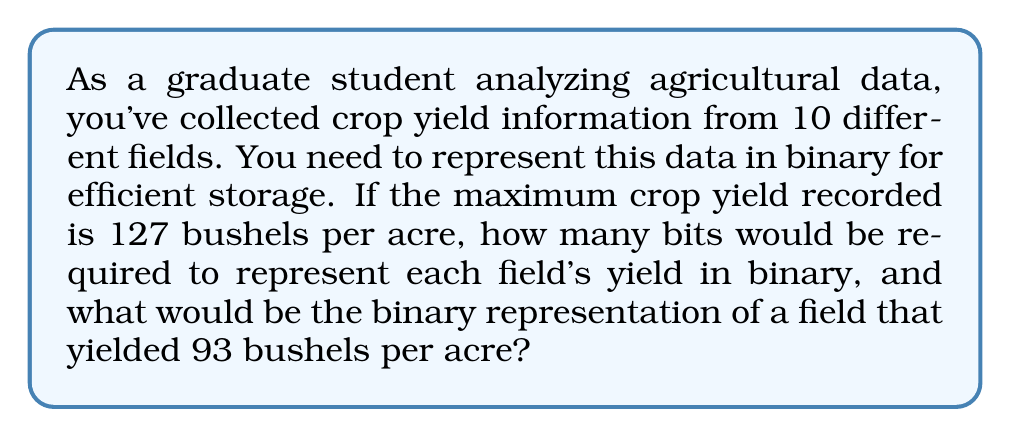Help me with this question. To solve this problem, we need to follow these steps:

1. Determine the number of bits required:
   The maximum yield is 127 bushels per acre. To find the number of bits, we need to find the smallest $n$ such that $2^n - 1 \geq 127$.

   $2^7 - 1 = 127$

   Therefore, 7 bits are required to represent yields up to 127.

2. Convert 93 to binary:
   To convert 93 to binary, we can use the division by 2 method:

   $$
   \begin{array}{r|l}
   93 \div 2 = 46 & \text{remainder } 1 \\
   46 \div 2 = 23 & \text{remainder } 0 \\
   23 \div 2 = 11 & \text{remainder } 1 \\
   11 \div 2 = 5  & \text{remainder } 1 \\
   5 \div 2 = 2   & \text{remainder } 1 \\
   2 \div 2 = 1   & \text{remainder } 0 \\
   1 \div 2 = 0   & \text{remainder } 1 \\
   \end{array}
   $$

   Reading the remainders from bottom to top gives us the binary representation:
   $93_{10} = 1011101_2$

   Since we need 7 bits to represent all possible values, we add a leading zero:
   $93_{10} = 01011101_2$
Answer: 7 bits are required to represent each field's yield, and the binary representation of 93 bushels per acre is $01011101_2$. 